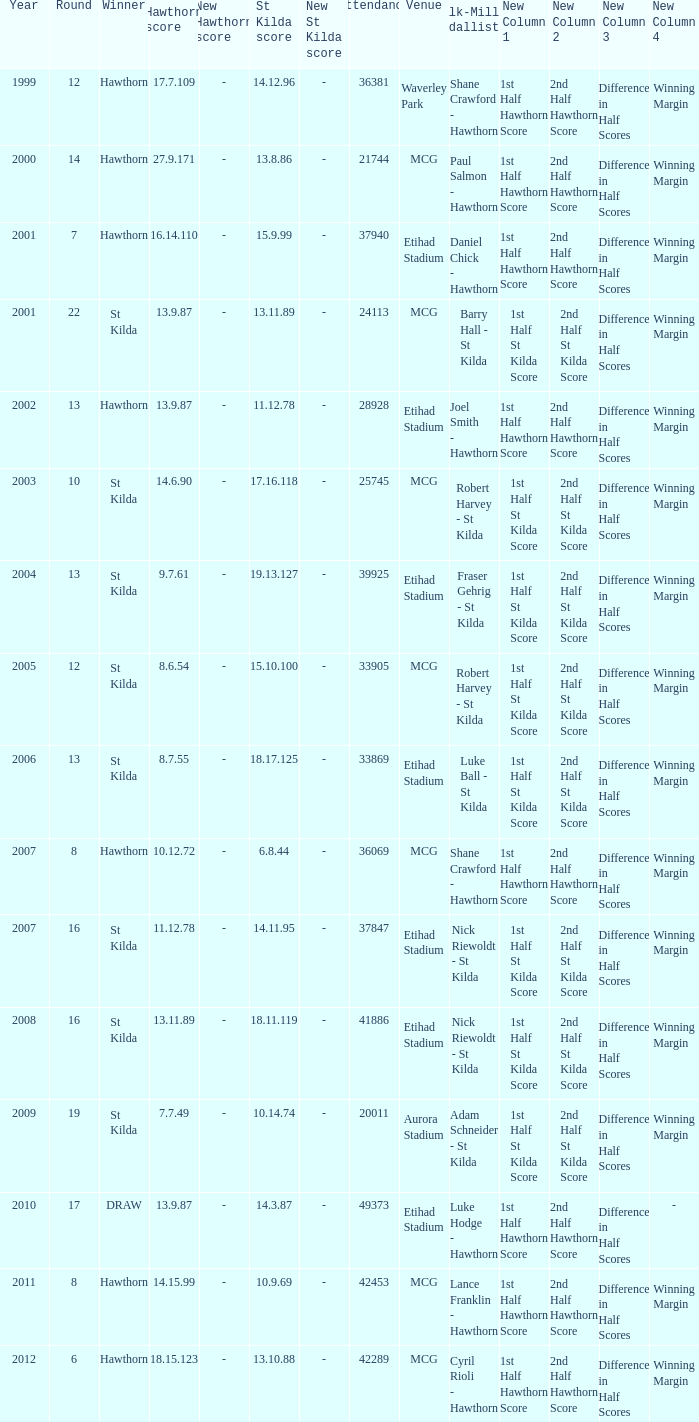What is the hawthorn score at the year 2000? 279171.0. 